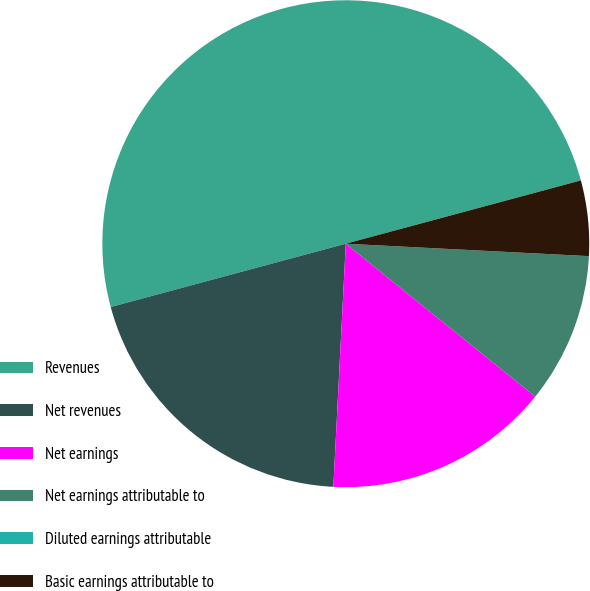Convert chart. <chart><loc_0><loc_0><loc_500><loc_500><pie_chart><fcel>Revenues<fcel>Net revenues<fcel>Net earnings<fcel>Net earnings attributable to<fcel>Diluted earnings attributable<fcel>Basic earnings attributable to<nl><fcel>50.0%<fcel>20.0%<fcel>15.0%<fcel>10.0%<fcel>0.0%<fcel>5.0%<nl></chart> 